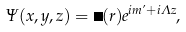<formula> <loc_0><loc_0><loc_500><loc_500>\Psi ( x , y , z ) = \psi ( r ) e ^ { i m \varphi + i \Lambda z } ,</formula> 